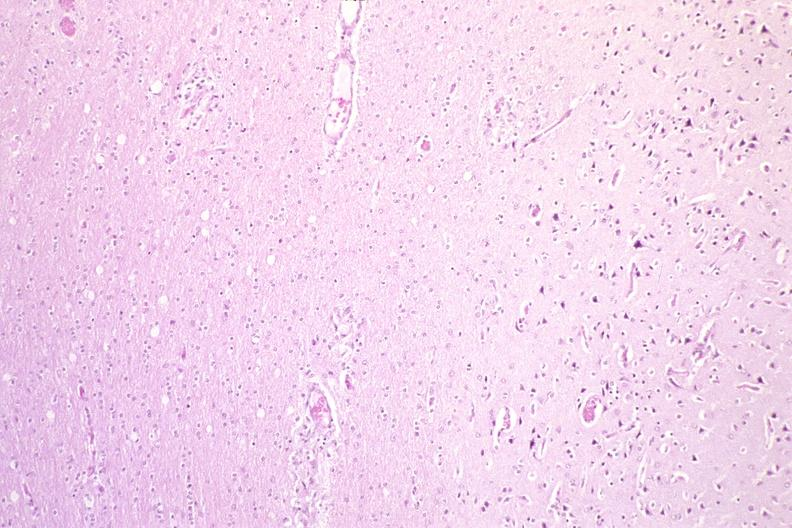what does this image show?
Answer the question using a single word or phrase. Brain 